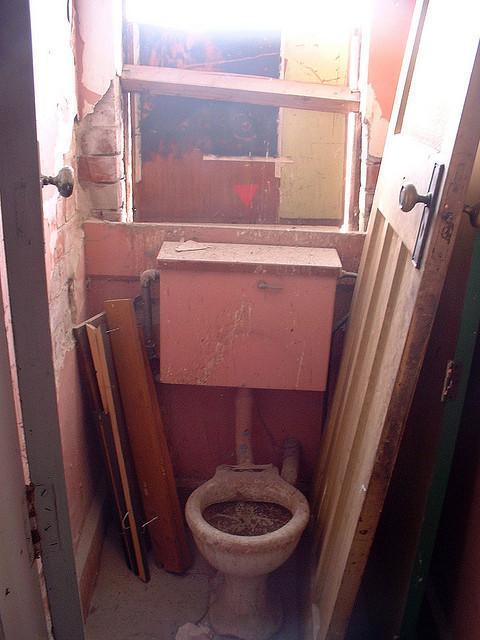How many people are actually skateboarding?
Give a very brief answer. 0. 